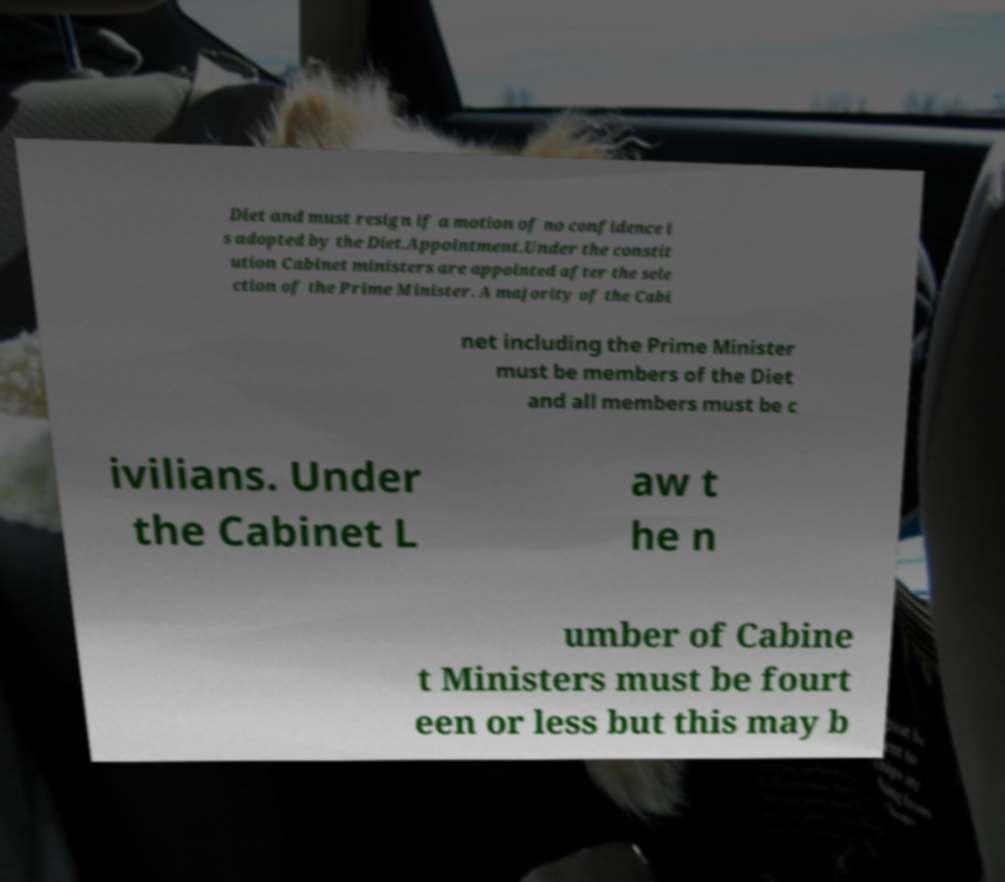Could you extract and type out the text from this image? Diet and must resign if a motion of no confidence i s adopted by the Diet.Appointment.Under the constit ution Cabinet ministers are appointed after the sele ction of the Prime Minister. A majority of the Cabi net including the Prime Minister must be members of the Diet and all members must be c ivilians. Under the Cabinet L aw t he n umber of Cabine t Ministers must be fourt een or less but this may b 